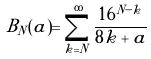Convert formula to latex. <formula><loc_0><loc_0><loc_500><loc_500>B _ { N } ( a ) = \sum _ { k = N } ^ { \infty } \frac { 1 6 ^ { N - k } } { 8 k + a }</formula> 